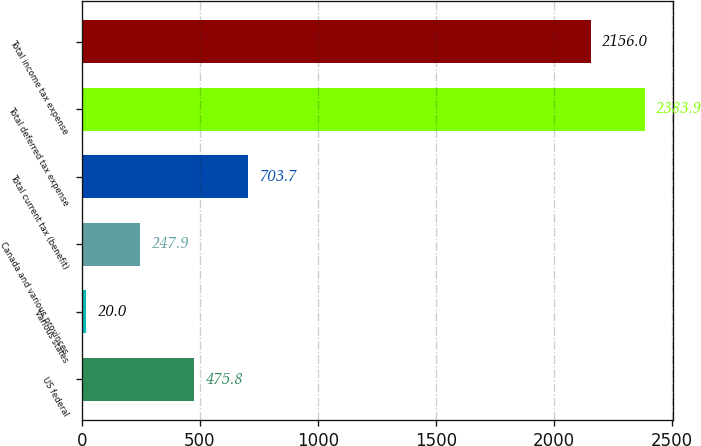Convert chart. <chart><loc_0><loc_0><loc_500><loc_500><bar_chart><fcel>US federal<fcel>Various states<fcel>Canada and various provinces<fcel>Total current tax (benefit)<fcel>Total deferred tax expense<fcel>Total income tax expense<nl><fcel>475.8<fcel>20<fcel>247.9<fcel>703.7<fcel>2383.9<fcel>2156<nl></chart> 